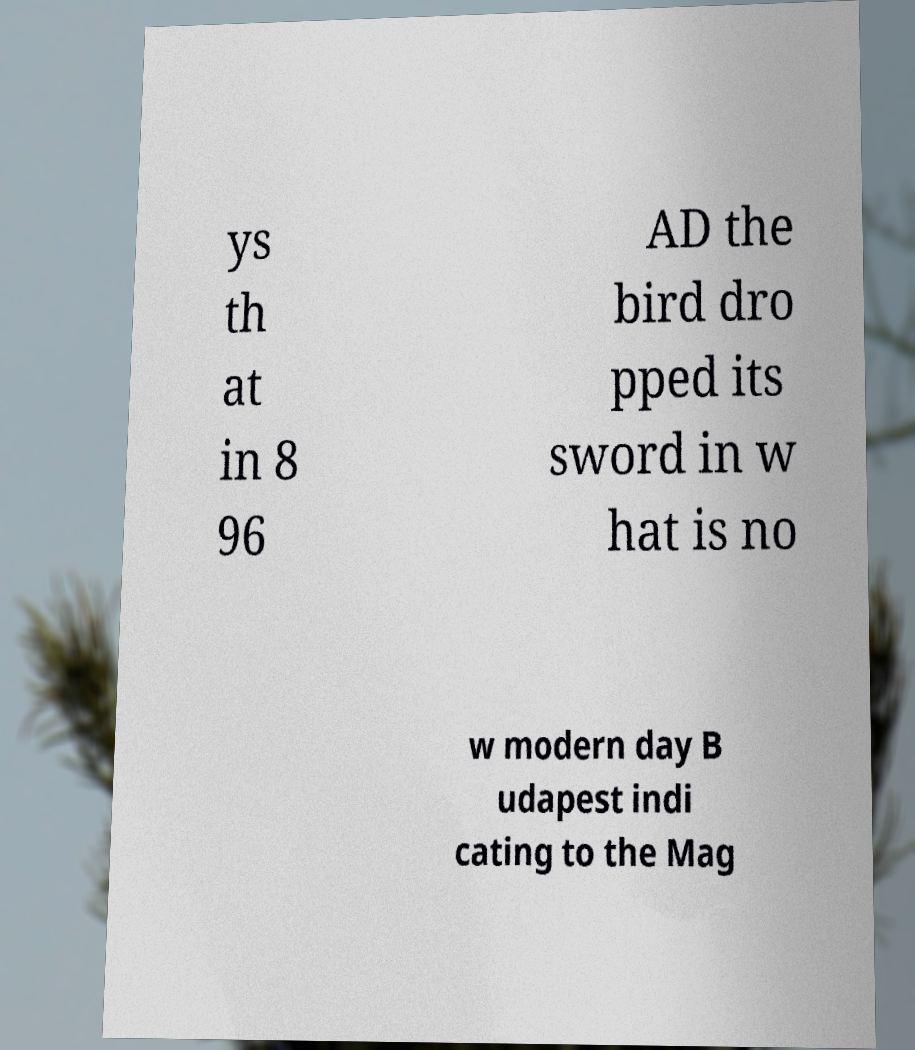Please read and relay the text visible in this image. What does it say? ys th at in 8 96 AD the bird dro pped its sword in w hat is no w modern day B udapest indi cating to the Mag 